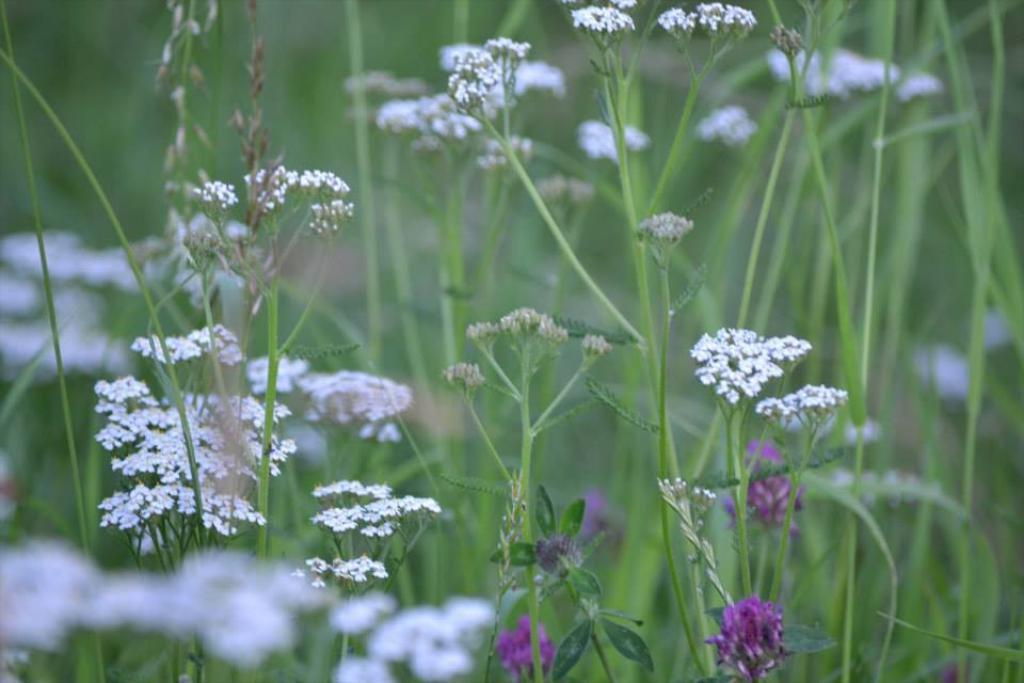What type of plants can be seen in the image? There are flowering plants in the image. What color is the grass in the image? The grass in the image is green. How many blocks of cheese can be seen in the image? There is no cheese present in the image. Are there any sheep grazing on the green grass in the image? There are no sheep present in the image. 